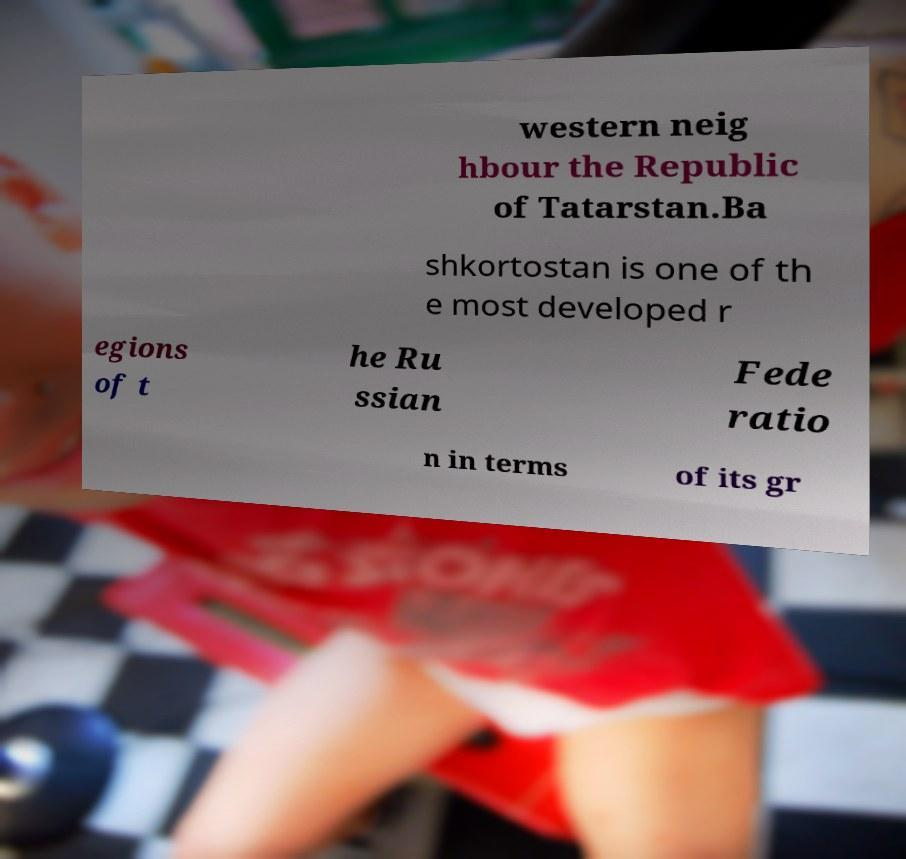There's text embedded in this image that I need extracted. Can you transcribe it verbatim? western neig hbour the Republic of Tatarstan.Ba shkortostan is one of th e most developed r egions of t he Ru ssian Fede ratio n in terms of its gr 